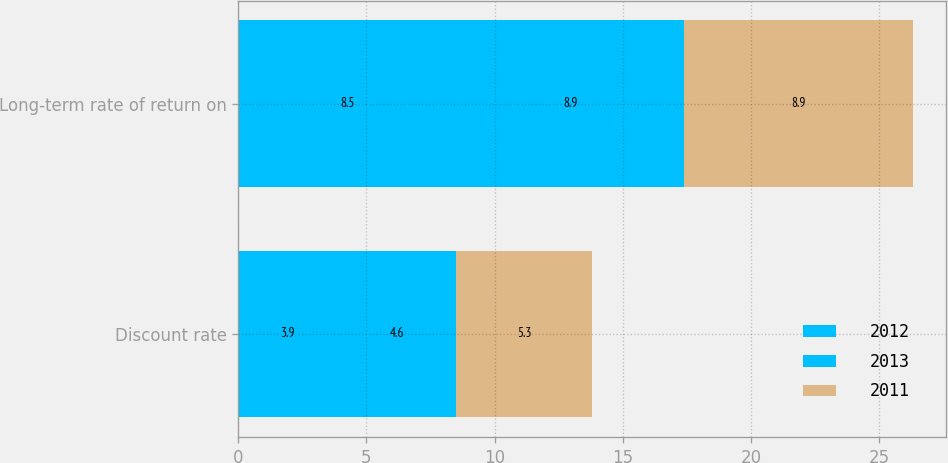Convert chart. <chart><loc_0><loc_0><loc_500><loc_500><stacked_bar_chart><ecel><fcel>Discount rate<fcel>Long-term rate of return on<nl><fcel>2012<fcel>3.9<fcel>8.5<nl><fcel>2013<fcel>4.6<fcel>8.9<nl><fcel>2011<fcel>5.3<fcel>8.9<nl></chart> 